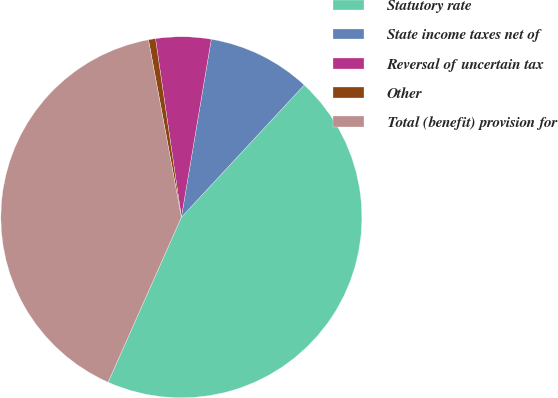Convert chart to OTSL. <chart><loc_0><loc_0><loc_500><loc_500><pie_chart><fcel>Statutory rate<fcel>State income taxes net of<fcel>Reversal of uncertain tax<fcel>Other<fcel>Total (benefit) provision for<nl><fcel>44.74%<fcel>9.26%<fcel>4.94%<fcel>0.63%<fcel>40.43%<nl></chart> 